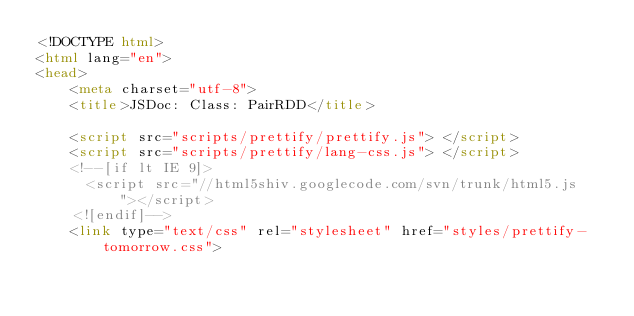Convert code to text. <code><loc_0><loc_0><loc_500><loc_500><_HTML_><!DOCTYPE html>
<html lang="en">
<head>
    <meta charset="utf-8">
    <title>JSDoc: Class: PairRDD</title>

    <script src="scripts/prettify/prettify.js"> </script>
    <script src="scripts/prettify/lang-css.js"> </script>
    <!--[if lt IE 9]>
      <script src="//html5shiv.googlecode.com/svn/trunk/html5.js"></script>
    <![endif]-->
    <link type="text/css" rel="stylesheet" href="styles/prettify-tomorrow.css"></code> 